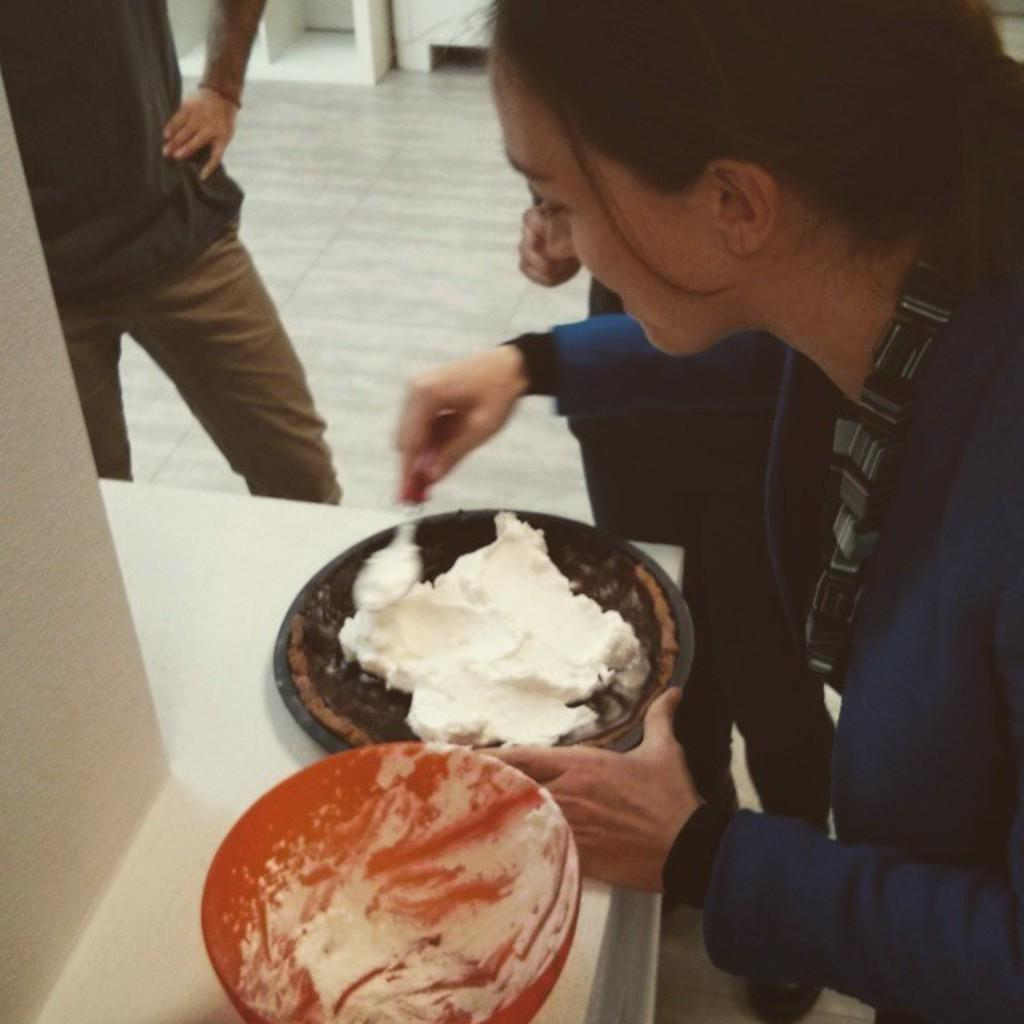Who or what is present in the image? There are people in the image. What objects can be seen in the image? There are bowls and cream on the platform visible in the image. What is the main surface in the image? The platform is visible in the image. What can be seen in the background of the image? There is a floor and white objects in the background of the image. Are there any fairies flying around the cream in the image? There are no fairies present in the image; it only features people, bowls, cream, and the platform. 